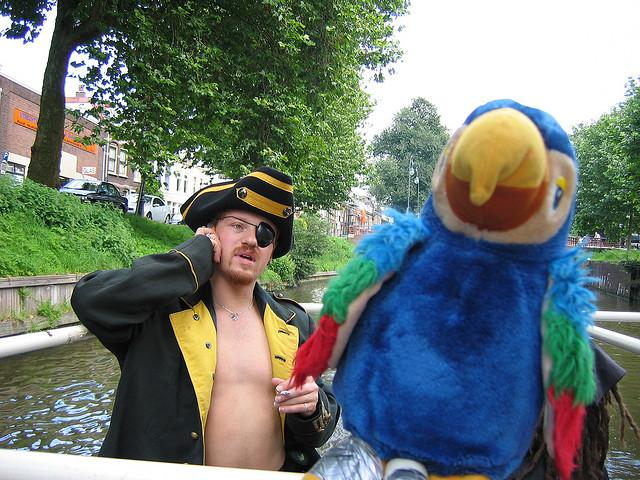What is the shirtless man dressed as? Please explain your reasoning. pirate. The man has an eye patch, a tricorne hat, and a parrot and one of the options is traditionally associated with those items. 